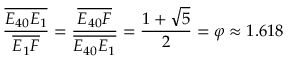<formula> <loc_0><loc_0><loc_500><loc_500>{ \frac { \overline { { E _ { 4 0 } E _ { 1 } } } } { \overline { { E _ { 1 } F } } } } = { \frac { \overline { { E _ { 4 0 } F } } } { \overline { { E _ { 4 0 } E _ { 1 } } } } } = { \frac { 1 + { \sqrt { 5 } } } { 2 } } = \varphi \approx 1 . 6 1 8</formula> 